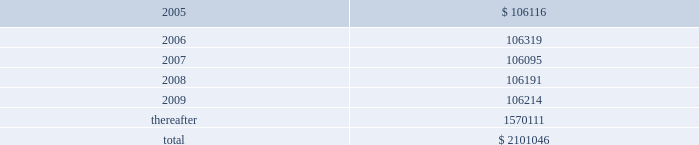American tower corporation and subsidiaries notes to consolidated financial statements 2014 ( continued ) 7 .
Derivative financial instruments under the terms of the credit facility , the company is required to enter into interest rate protection agreements on at least 50% ( 50 % ) of its variable rate debt .
Under these agreements , the company is exposed to credit risk to the extent that a counterparty fails to meet the terms of a contract .
Such exposure is limited to the current value of the contract at the time the counterparty fails to perform .
The company believes its contracts as of december 31 , 2004 are with credit worthy institutions .
As of december 31 , 2004 , the company had two interest rate caps outstanding with an aggregate notional amount of $ 350.0 million ( each at an interest rate of 6.0% ( 6.0 % ) ) that expire in 2006 .
As of december 31 , 2003 , the company had three interest rate caps outstanding with an aggregate notional amount of $ 500.0 million ( each at a rate of 5.0% ( 5.0 % ) ) that expired in 2004 .
As of december 31 , 2004 and 2003 , there was no fair value associated with any of these interest rate caps .
During the year ended december 31 , 2003 , the company recorded an unrealized loss of approximately $ 0.3 million ( net of a tax benefit of approximately $ 0.2 million ) in other comprehensive loss for the change in fair value of cash flow hedges and reclassified $ 5.9 million ( net of a tax benefit of approximately $ 3.2 million ) into results of operations .
During the year ended december 31 , 2002 , the company recorded an unrealized loss of approximately $ 9.1 million ( net of a tax benefit of approximately $ 4.9 million ) in other comprehensive loss for the change in fair value of cash flow hedges and reclassified $ 19.5 million ( net of a tax benefit of approximately $ 10.5 million ) into results of operations .
Hedge ineffectiveness resulted in a gain of approximately $ 1.0 million for the year ended december 31 , 2002 , which is recorded in other expense in the accompanying consolidated statement of operations .
The company records the changes in fair value of its derivative instruments that are not accounted for as hedges in other expense .
The company did not reclassify any derivative losses into its statement of operations for the year ended december 31 , 2004 and does not anticipate reclassifying any derivative losses into its statement of operations within the next twelve months , as there are no amounts included in other comprehensive loss as of december 31 , 2004 .
Commitments and contingencies lease obligations 2014the company leases certain land , office and tower space under operating leases that expire over various terms .
Many of the leases contain renewal options with specified increases in lease payments upon exercise of the renewal option .
Escalation clauses present in operating leases , excluding those tied to cpi or other inflation-based indices , are straight-lined over the term of the lease .
( see note 1. ) future minimum rental payments under non-cancelable operating leases include payments for certain renewal periods at the company 2019s option because failure to renew could result in a loss of the applicable tower site and related revenues from tenant leases , thereby making it reasonably assured that the company will renew the lease .
Such payments in effect at december 31 , 2004 are as follows ( in thousands ) : year ending december 31 .
Aggregate rent expense ( including the effect of straight-line rent expense ) under operating leases for the years ended december 31 , 2004 , 2003 and 2002 approximated $ 118741000 , $ 113956000 , and $ 109644000 , respectively. .
What is the percentage change in aggregate rent expense from 2003 to 2004? 
Computations: ((118741000 - 113956000) / 113956000)
Answer: 0.04199. 